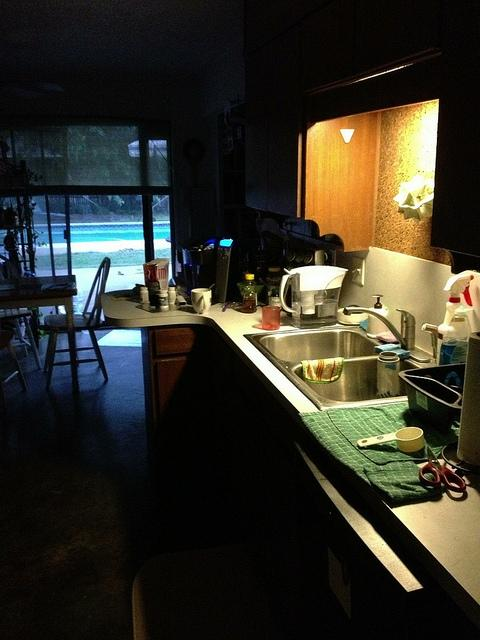What is to the right of the sink? towel 